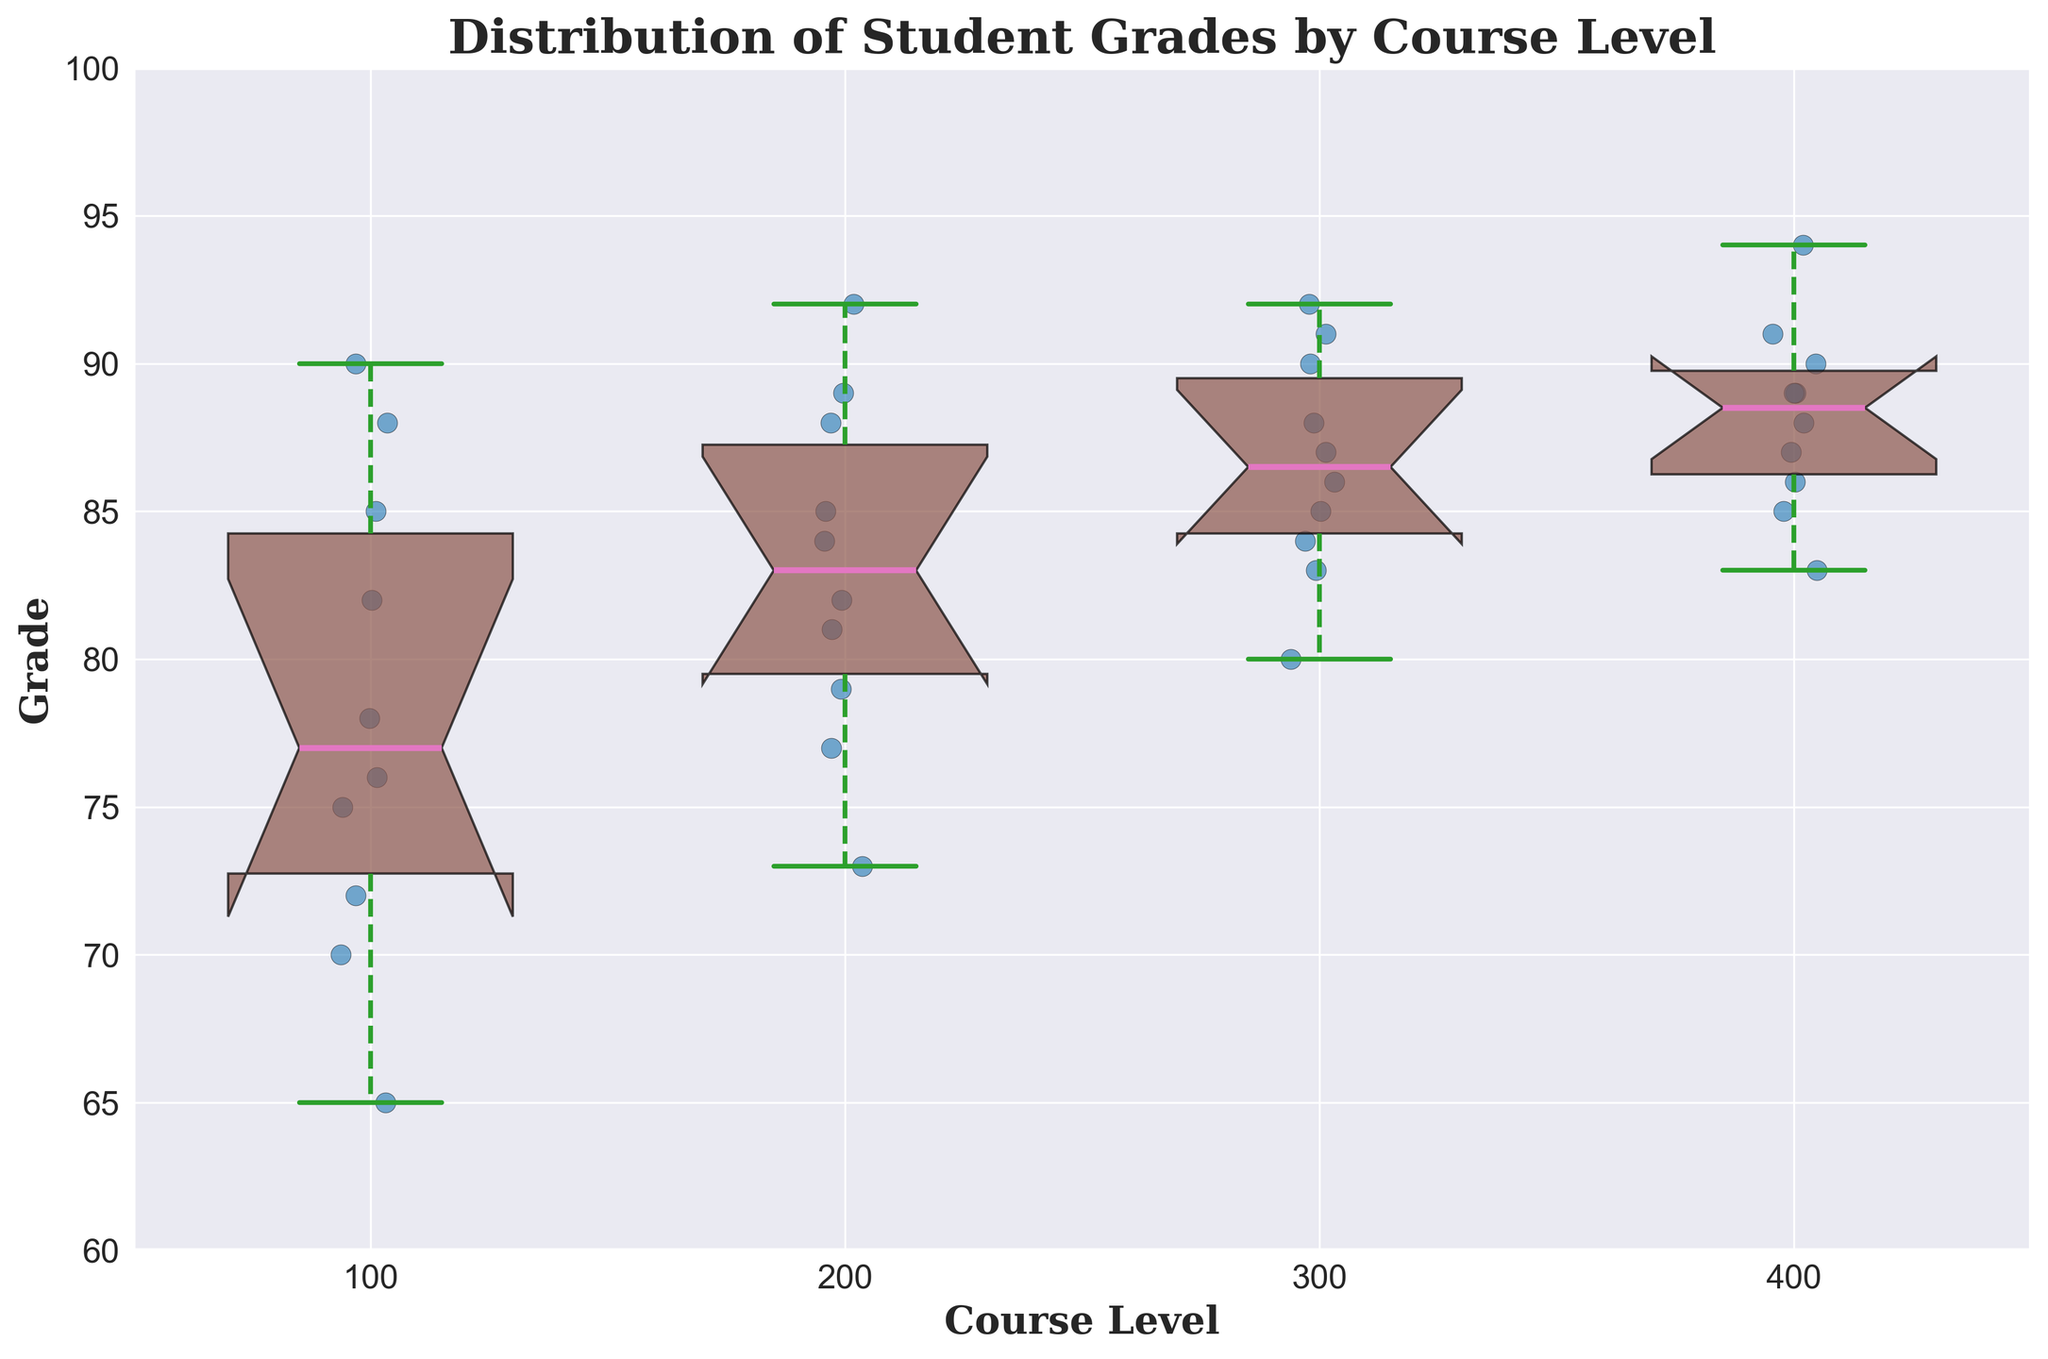What is the title of the figure? The title is typically placed at the top of the figure and is intended to give a brief summary of what the figure is about. Here, it can be seen clearly as "Distribution of Student Grades by Course Level".
Answer: Distribution of Student Grades by Course Level What is the range of grades shown in the Y-axis? The Y-axis shows the range of grades. The lowest value on the Y-axis is 60 and the highest value is 100, as indicated by the axis markings.
Answer: 60 to 100 Which course level has the highest median grade? To determine the highest median grade, look for the median line (colored differently, typically pink in this case) inside each box. For 400-level courses, the median line is the highest among all course levels.
Answer: 400 How many data points are there for the 200-level course? To find the number of data points for the 200-level course, count the scatter points (blue dots) within that box plot. Each dot represents a student's grade.
Answer: 10 Which course level has the smallest interquartile range (IQR)? The interquartile range is the height of the box in a box plot. The 400-level course has the smallest IQR as its box appears the shortest compared to other course levels.
Answer: 400 What is the approximate median grade for 300-level courses? The median is represented by the line inside the box. For 300-level courses, this line is slightly below 90, making the median approximately 89.
Answer: approximately 89 Compare the median grades of 100-level and 200-level courses. Which is higher and by approximately how much? The median for 100-level courses is just below 80, and for 200-level courses, it is slightly above 82. Therefore, the median for 200-level is higher by approximately 2 points.
Answer: 200-level is higher by approximately 2 points Which course level has the widest range of grades, considering the whiskers? To find the widest range, look at the length of the whiskers (dotted lines extending from the box). The 300-level course has the longest whiskers, indicating the widest range.
Answer: 300 Are there any outliers, and if so, for which course levels? Outliers are represented by diamond-shaped markers away from the whiskers. In this figure, there are no outliers indicated for any course level, as no diamond markers are present.
Answer: No outliers 